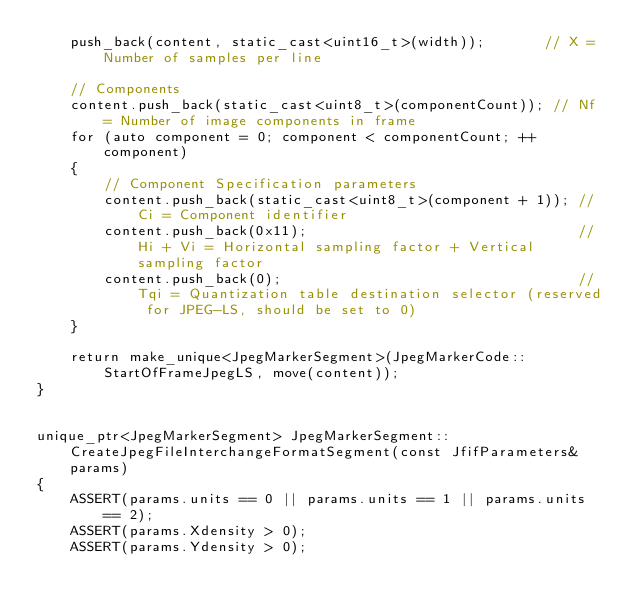Convert code to text. <code><loc_0><loc_0><loc_500><loc_500><_C++_>    push_back(content, static_cast<uint16_t>(width));       // X = Number of samples per line

    // Components
    content.push_back(static_cast<uint8_t>(componentCount)); // Nf = Number of image components in frame
    for (auto component = 0; component < componentCount; ++component)
    {
        // Component Specification parameters
        content.push_back(static_cast<uint8_t>(component + 1)); // Ci = Component identifier
        content.push_back(0x11);                                // Hi + Vi = Horizontal sampling factor + Vertical sampling factor
        content.push_back(0);                                   // Tqi = Quantization table destination selector (reserved for JPEG-LS, should be set to 0)
    }

    return make_unique<JpegMarkerSegment>(JpegMarkerCode::StartOfFrameJpegLS, move(content));
}


unique_ptr<JpegMarkerSegment> JpegMarkerSegment::CreateJpegFileInterchangeFormatSegment(const JfifParameters& params)
{
    ASSERT(params.units == 0 || params.units == 1 || params.units == 2);
    ASSERT(params.Xdensity > 0);
    ASSERT(params.Ydensity > 0);</code> 